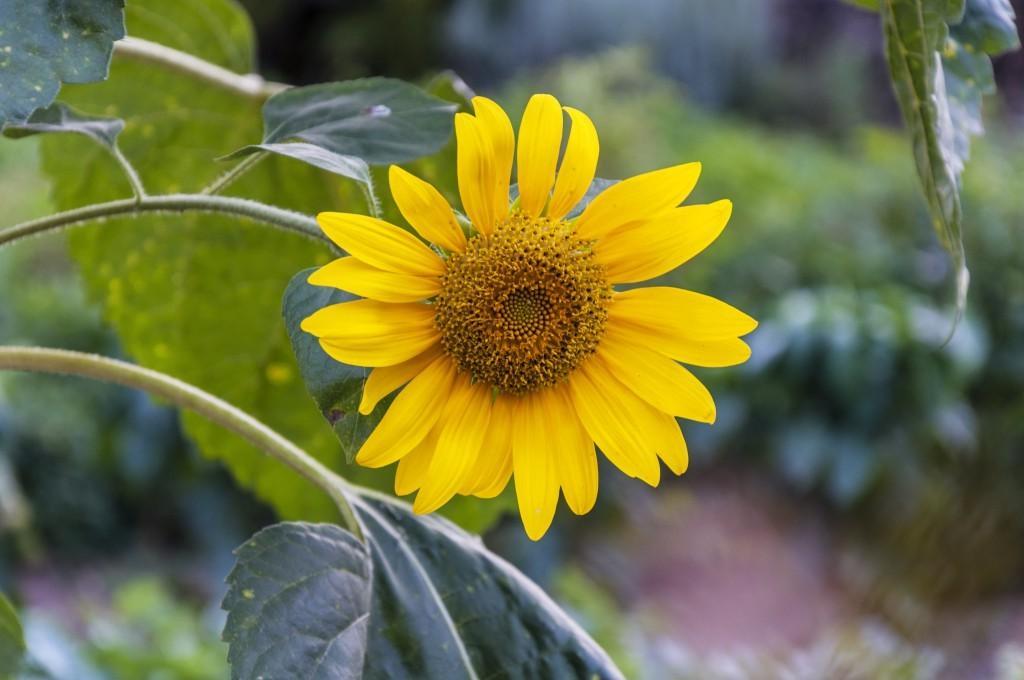How would you summarize this image in a sentence or two? In this image there is a plant having flower and leaves to it. Flower is in yellow color. Background there are few plants on the land. 